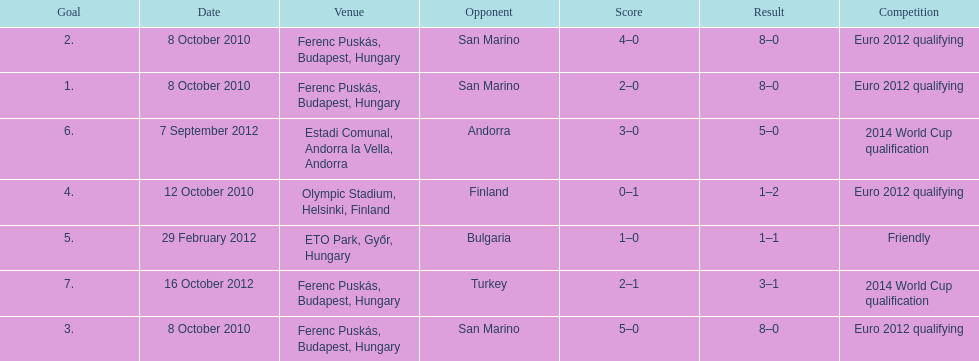How many games did he score but his team lost? 1. Would you be able to parse every entry in this table? {'header': ['Goal', 'Date', 'Venue', 'Opponent', 'Score', 'Result', 'Competition'], 'rows': [['2.', '8 October 2010', 'Ferenc Puskás, Budapest, Hungary', 'San Marino', '4–0', '8–0', 'Euro 2012 qualifying'], ['1.', '8 October 2010', 'Ferenc Puskás, Budapest, Hungary', 'San Marino', '2–0', '8–0', 'Euro 2012 qualifying'], ['6.', '7 September 2012', 'Estadi Comunal, Andorra la Vella, Andorra', 'Andorra', '3–0', '5–0', '2014 World Cup qualification'], ['4.', '12 October 2010', 'Olympic Stadium, Helsinki, Finland', 'Finland', '0–1', '1–2', 'Euro 2012 qualifying'], ['5.', '29 February 2012', 'ETO Park, Győr, Hungary', 'Bulgaria', '1–0', '1–1', 'Friendly'], ['7.', '16 October 2012', 'Ferenc Puskás, Budapest, Hungary', 'Turkey', '2–1', '3–1', '2014 World Cup qualification'], ['3.', '8 October 2010', 'Ferenc Puskás, Budapest, Hungary', 'San Marino', '5–0', '8–0', 'Euro 2012 qualifying']]} 